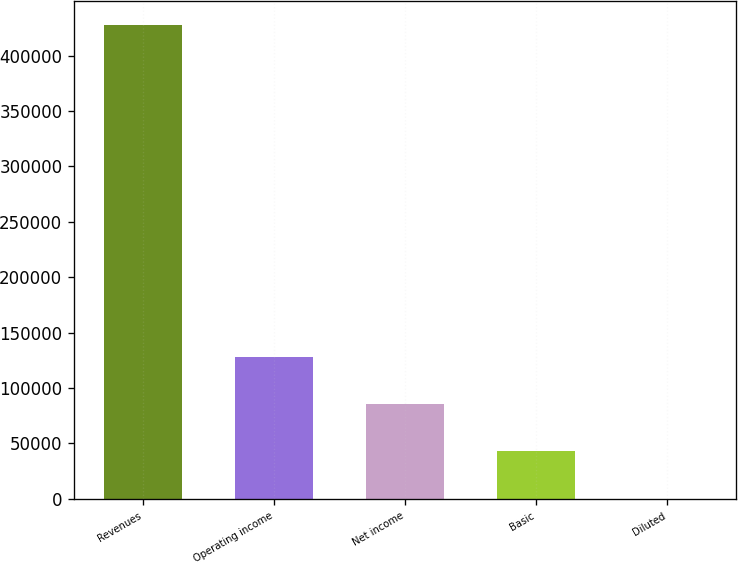Convert chart. <chart><loc_0><loc_0><loc_500><loc_500><bar_chart><fcel>Revenues<fcel>Operating income<fcel>Net income<fcel>Basic<fcel>Diluted<nl><fcel>427694<fcel>128309<fcel>85539.2<fcel>42769.8<fcel>0.46<nl></chart> 